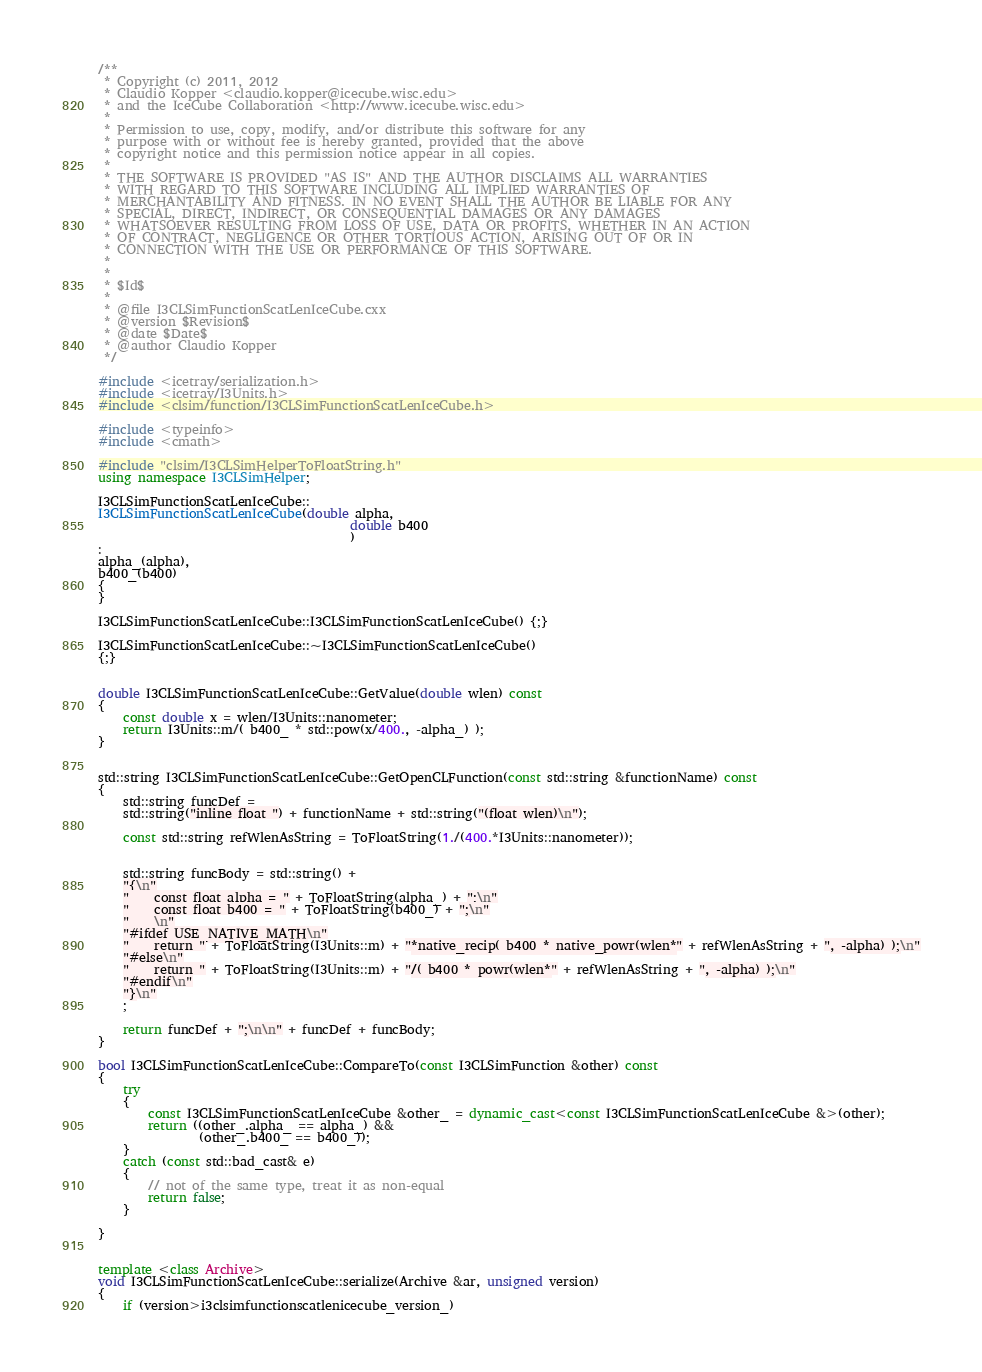Convert code to text. <code><loc_0><loc_0><loc_500><loc_500><_C++_>/**
 * Copyright (c) 2011, 2012
 * Claudio Kopper <claudio.kopper@icecube.wisc.edu>
 * and the IceCube Collaboration <http://www.icecube.wisc.edu>
 *
 * Permission to use, copy, modify, and/or distribute this software for any
 * purpose with or without fee is hereby granted, provided that the above
 * copyright notice and this permission notice appear in all copies.
 *
 * THE SOFTWARE IS PROVIDED "AS IS" AND THE AUTHOR DISCLAIMS ALL WARRANTIES
 * WITH REGARD TO THIS SOFTWARE INCLUDING ALL IMPLIED WARRANTIES OF
 * MERCHANTABILITY AND FITNESS. IN NO EVENT SHALL THE AUTHOR BE LIABLE FOR ANY
 * SPECIAL, DIRECT, INDIRECT, OR CONSEQUENTIAL DAMAGES OR ANY DAMAGES
 * WHATSOEVER RESULTING FROM LOSS OF USE, DATA OR PROFITS, WHETHER IN AN ACTION
 * OF CONTRACT, NEGLIGENCE OR OTHER TORTIOUS ACTION, ARISING OUT OF OR IN
 * CONNECTION WITH THE USE OR PERFORMANCE OF THIS SOFTWARE.
 *
 *
 * $Id$
 *
 * @file I3CLSimFunctionScatLenIceCube.cxx
 * @version $Revision$
 * @date $Date$
 * @author Claudio Kopper
 */

#include <icetray/serialization.h>
#include <icetray/I3Units.h>
#include <clsim/function/I3CLSimFunctionScatLenIceCube.h>

#include <typeinfo>
#include <cmath>

#include "clsim/I3CLSimHelperToFloatString.h"
using namespace I3CLSimHelper;

I3CLSimFunctionScatLenIceCube::
I3CLSimFunctionScatLenIceCube(double alpha,
                                        double b400
                                        )
:
alpha_(alpha),
b400_(b400)
{ 
}

I3CLSimFunctionScatLenIceCube::I3CLSimFunctionScatLenIceCube() {;}

I3CLSimFunctionScatLenIceCube::~I3CLSimFunctionScatLenIceCube() 
{;}


double I3CLSimFunctionScatLenIceCube::GetValue(double wlen) const
{
    const double x = wlen/I3Units::nanometer;
    return I3Units::m/( b400_ * std::pow(x/400., -alpha_) );
}


std::string I3CLSimFunctionScatLenIceCube::GetOpenCLFunction(const std::string &functionName) const
{
    std::string funcDef = 
    std::string("inline float ") + functionName + std::string("(float wlen)\n");

    const std::string refWlenAsString = ToFloatString(1./(400.*I3Units::nanometer));
    
    
    std::string funcBody = std::string() + 
    "{\n"
    "    const float alpha = " + ToFloatString(alpha_) + ";\n"
    "    const float b400 = " + ToFloatString(b400_) + ";\n"
    "    \n"
    "#ifdef USE_NATIVE_MATH\n"
    "    return " + ToFloatString(I3Units::m) + "*native_recip( b400 * native_powr(wlen*" + refWlenAsString + ", -alpha) );\n"
    "#else\n"
    "    return " + ToFloatString(I3Units::m) + "/( b400 * powr(wlen*" + refWlenAsString + ", -alpha) );\n"
    "#endif\n"
    "}\n"
    ;
    
    return funcDef + ";\n\n" + funcDef + funcBody;
}

bool I3CLSimFunctionScatLenIceCube::CompareTo(const I3CLSimFunction &other) const
{
    try
    {
        const I3CLSimFunctionScatLenIceCube &other_ = dynamic_cast<const I3CLSimFunctionScatLenIceCube &>(other);
        return ((other_.alpha_ == alpha_) &&
                (other_.b400_ == b400_));
    }
    catch (const std::bad_cast& e)
    {
        // not of the same type, treat it as non-equal
        return false;
    }
    
}


template <class Archive>
void I3CLSimFunctionScatLenIceCube::serialize(Archive &ar, unsigned version)
{
    if (version>i3clsimfunctionscatlenicecube_version_)</code> 